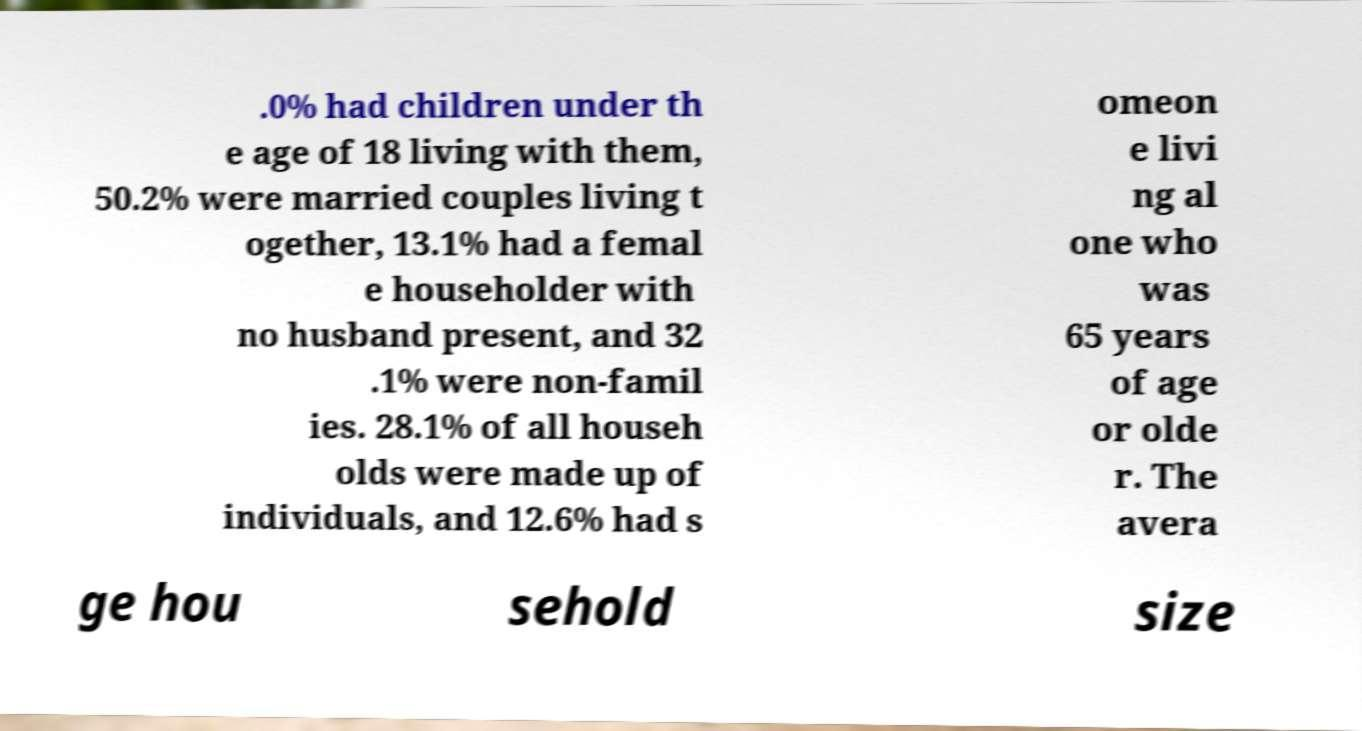What messages or text are displayed in this image? I need them in a readable, typed format. .0% had children under th e age of 18 living with them, 50.2% were married couples living t ogether, 13.1% had a femal e householder with no husband present, and 32 .1% were non-famil ies. 28.1% of all househ olds were made up of individuals, and 12.6% had s omeon e livi ng al one who was 65 years of age or olde r. The avera ge hou sehold size 